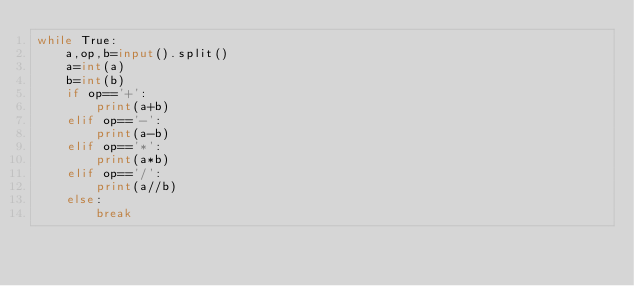Convert code to text. <code><loc_0><loc_0><loc_500><loc_500><_Python_>while True:
    a,op,b=input().split()
    a=int(a)
    b=int(b)
    if op=='+':
        print(a+b)
    elif op=='-':
        print(a-b)
    elif op=='*':
        print(a*b)
    elif op=='/':
        print(a//b)
    else:
        break
</code> 